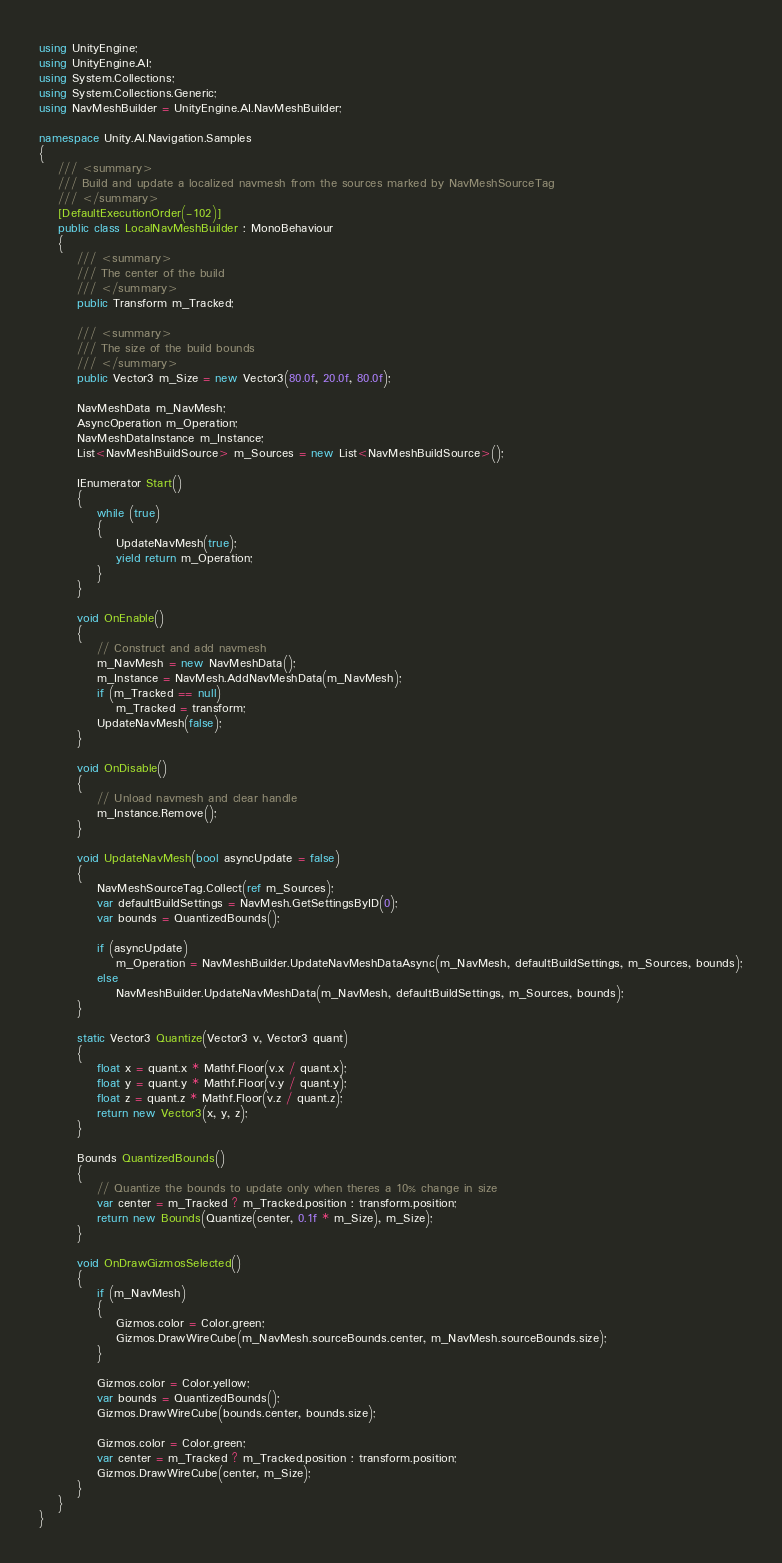Convert code to text. <code><loc_0><loc_0><loc_500><loc_500><_C#_>using UnityEngine;
using UnityEngine.AI;
using System.Collections;
using System.Collections.Generic;
using NavMeshBuilder = UnityEngine.AI.NavMeshBuilder;

namespace Unity.AI.Navigation.Samples
{
    /// <summary>
    /// Build and update a localized navmesh from the sources marked by NavMeshSourceTag 
    /// </summary>
    [DefaultExecutionOrder(-102)]
    public class LocalNavMeshBuilder : MonoBehaviour
    {
        /// <summary>
        /// The center of the build 
        /// </summary>
        public Transform m_Tracked;
    
        /// <summary>
        /// The size of the build bounds 
        /// </summary>
        public Vector3 m_Size = new Vector3(80.0f, 20.0f, 80.0f);
    
        NavMeshData m_NavMesh;
        AsyncOperation m_Operation;
        NavMeshDataInstance m_Instance;
        List<NavMeshBuildSource> m_Sources = new List<NavMeshBuildSource>();
    
        IEnumerator Start()
        {
            while (true)
            {
                UpdateNavMesh(true);
                yield return m_Operation;
            }
        }
    
        void OnEnable()
        {
            // Construct and add navmesh
            m_NavMesh = new NavMeshData();
            m_Instance = NavMesh.AddNavMeshData(m_NavMesh);
            if (m_Tracked == null)
                m_Tracked = transform;
            UpdateNavMesh(false);
        }
    
        void OnDisable()
        {
            // Unload navmesh and clear handle
            m_Instance.Remove();
        }
    
        void UpdateNavMesh(bool asyncUpdate = false)
        {
            NavMeshSourceTag.Collect(ref m_Sources);
            var defaultBuildSettings = NavMesh.GetSettingsByID(0);
            var bounds = QuantizedBounds();
    
            if (asyncUpdate)
                m_Operation = NavMeshBuilder.UpdateNavMeshDataAsync(m_NavMesh, defaultBuildSettings, m_Sources, bounds);
            else
                NavMeshBuilder.UpdateNavMeshData(m_NavMesh, defaultBuildSettings, m_Sources, bounds);
        }
    
        static Vector3 Quantize(Vector3 v, Vector3 quant)
        {
            float x = quant.x * Mathf.Floor(v.x / quant.x);
            float y = quant.y * Mathf.Floor(v.y / quant.y);
            float z = quant.z * Mathf.Floor(v.z / quant.z);
            return new Vector3(x, y, z);
        }
    
        Bounds QuantizedBounds()
        {
            // Quantize the bounds to update only when theres a 10% change in size
            var center = m_Tracked ? m_Tracked.position : transform.position;
            return new Bounds(Quantize(center, 0.1f * m_Size), m_Size);
        }
    
        void OnDrawGizmosSelected()
        {
            if (m_NavMesh)
            {
                Gizmos.color = Color.green;
                Gizmos.DrawWireCube(m_NavMesh.sourceBounds.center, m_NavMesh.sourceBounds.size);
            }
    
            Gizmos.color = Color.yellow;
            var bounds = QuantizedBounds();
            Gizmos.DrawWireCube(bounds.center, bounds.size);
    
            Gizmos.color = Color.green;
            var center = m_Tracked ? m_Tracked.position : transform.position;
            Gizmos.DrawWireCube(center, m_Size);
        }
    }
}</code> 